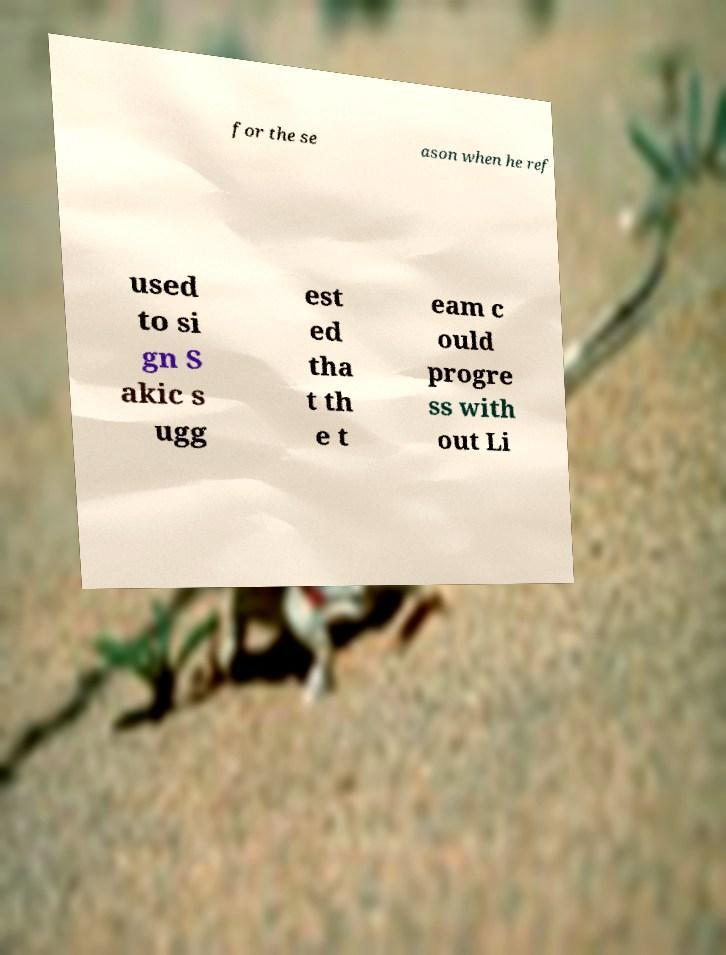Please identify and transcribe the text found in this image. for the se ason when he ref used to si gn S akic s ugg est ed tha t th e t eam c ould progre ss with out Li 